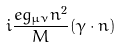Convert formula to latex. <formula><loc_0><loc_0><loc_500><loc_500>i \frac { e g _ { \mu \nu } n ^ { 2 } } { M } ( \gamma \cdot n )</formula> 